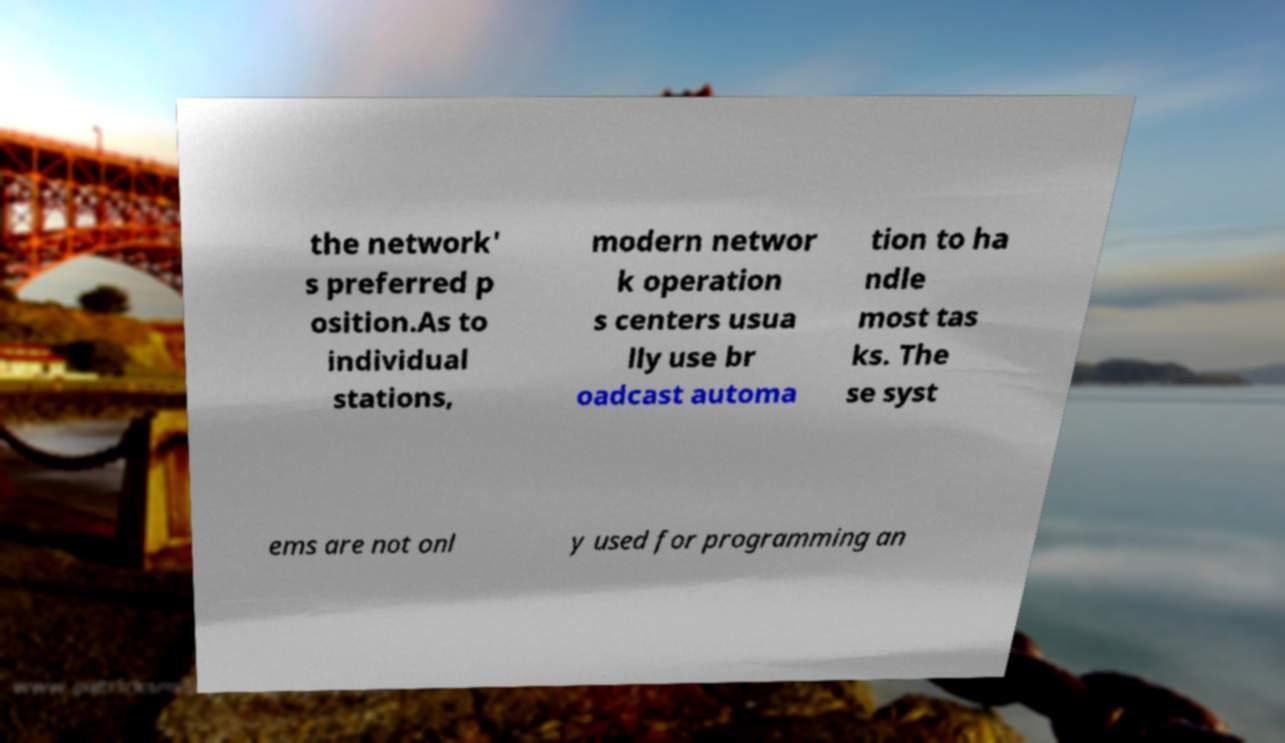For documentation purposes, I need the text within this image transcribed. Could you provide that? the network' s preferred p osition.As to individual stations, modern networ k operation s centers usua lly use br oadcast automa tion to ha ndle most tas ks. The se syst ems are not onl y used for programming an 